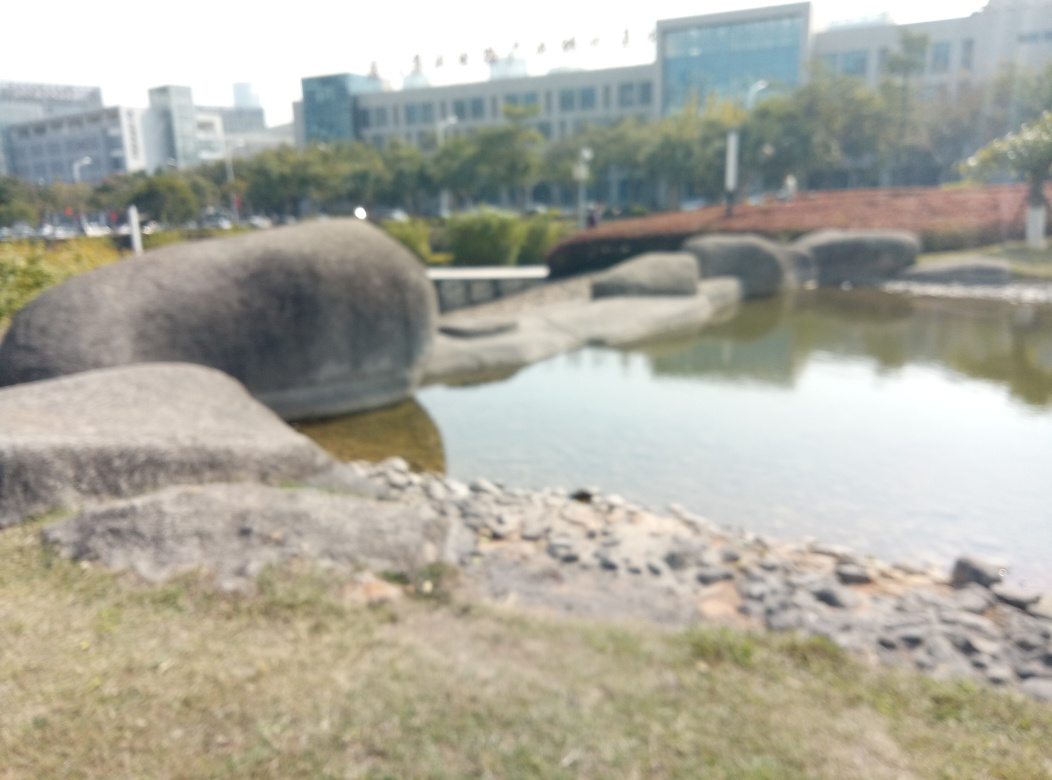What time of day does this image seem to depict? The image suggests a time of day that is likely midday or early afternoon, as indicated by the bright ambient light and lack of long shadows that would be present in the mornings or late afternoons. Is there a particular season that this image might represent? Given the green foliage and absence of any fallen leaves or snow, it is plausible that the image portrays a scene from late spring to early autumn. The specific season cannot be determined definitively without additional context clues. 